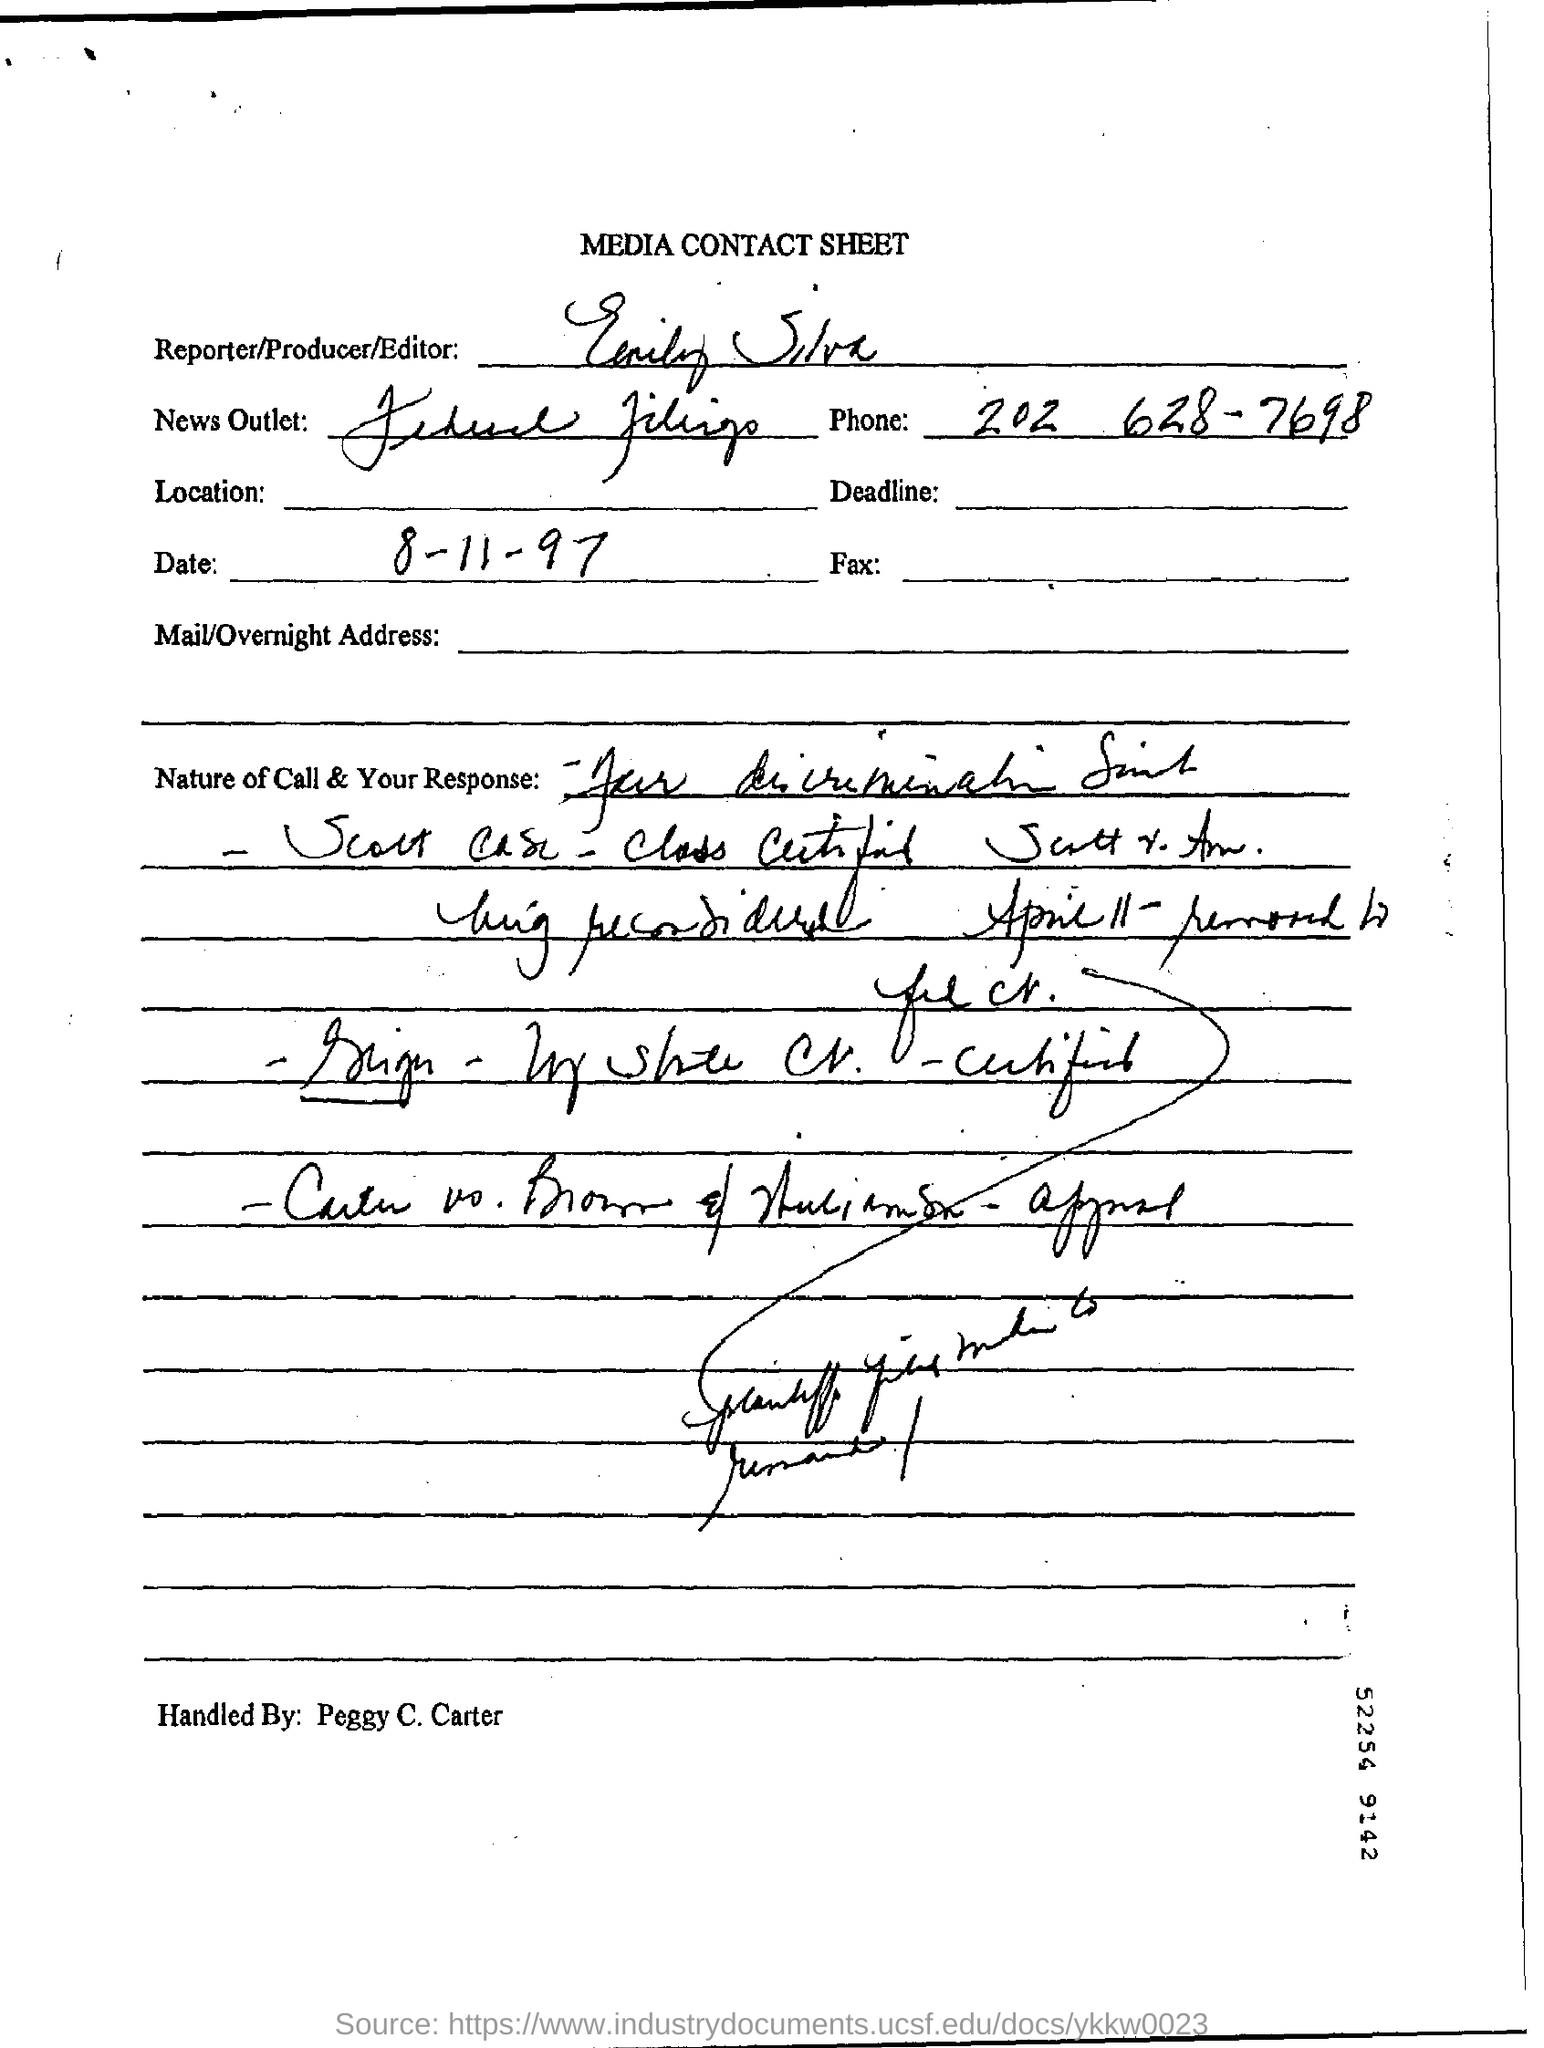Mention a couple of crucial points in this snapshot. The date is August 11, 1997. 